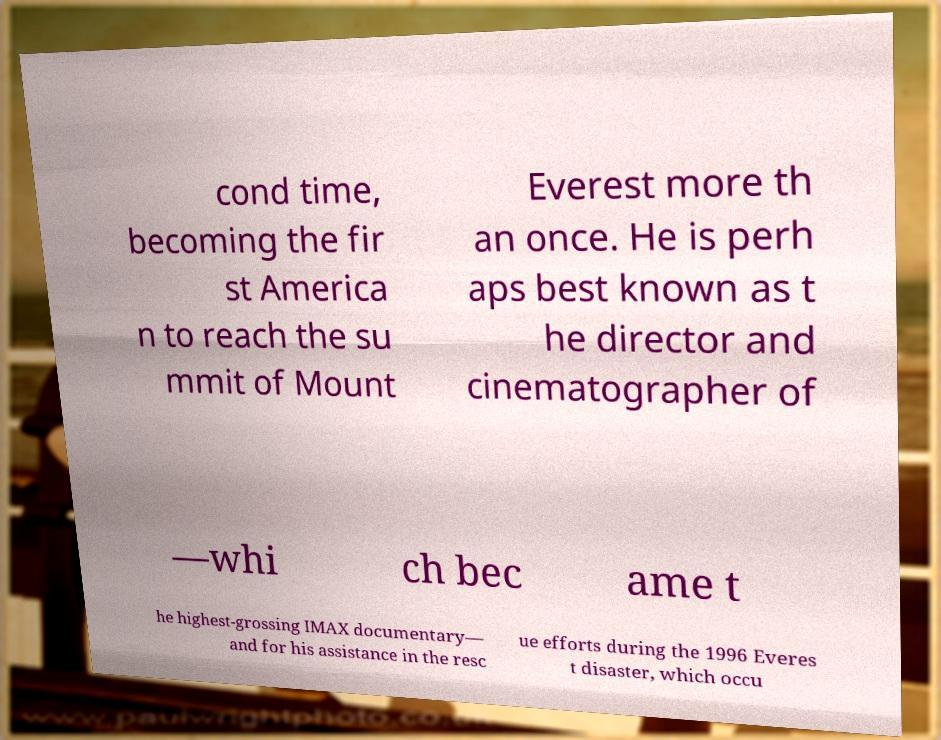Can you accurately transcribe the text from the provided image for me? cond time, becoming the fir st America n to reach the su mmit of Mount Everest more th an once. He is perh aps best known as t he director and cinematographer of —whi ch bec ame t he highest-grossing IMAX documentary— and for his assistance in the resc ue efforts during the 1996 Everes t disaster, which occu 